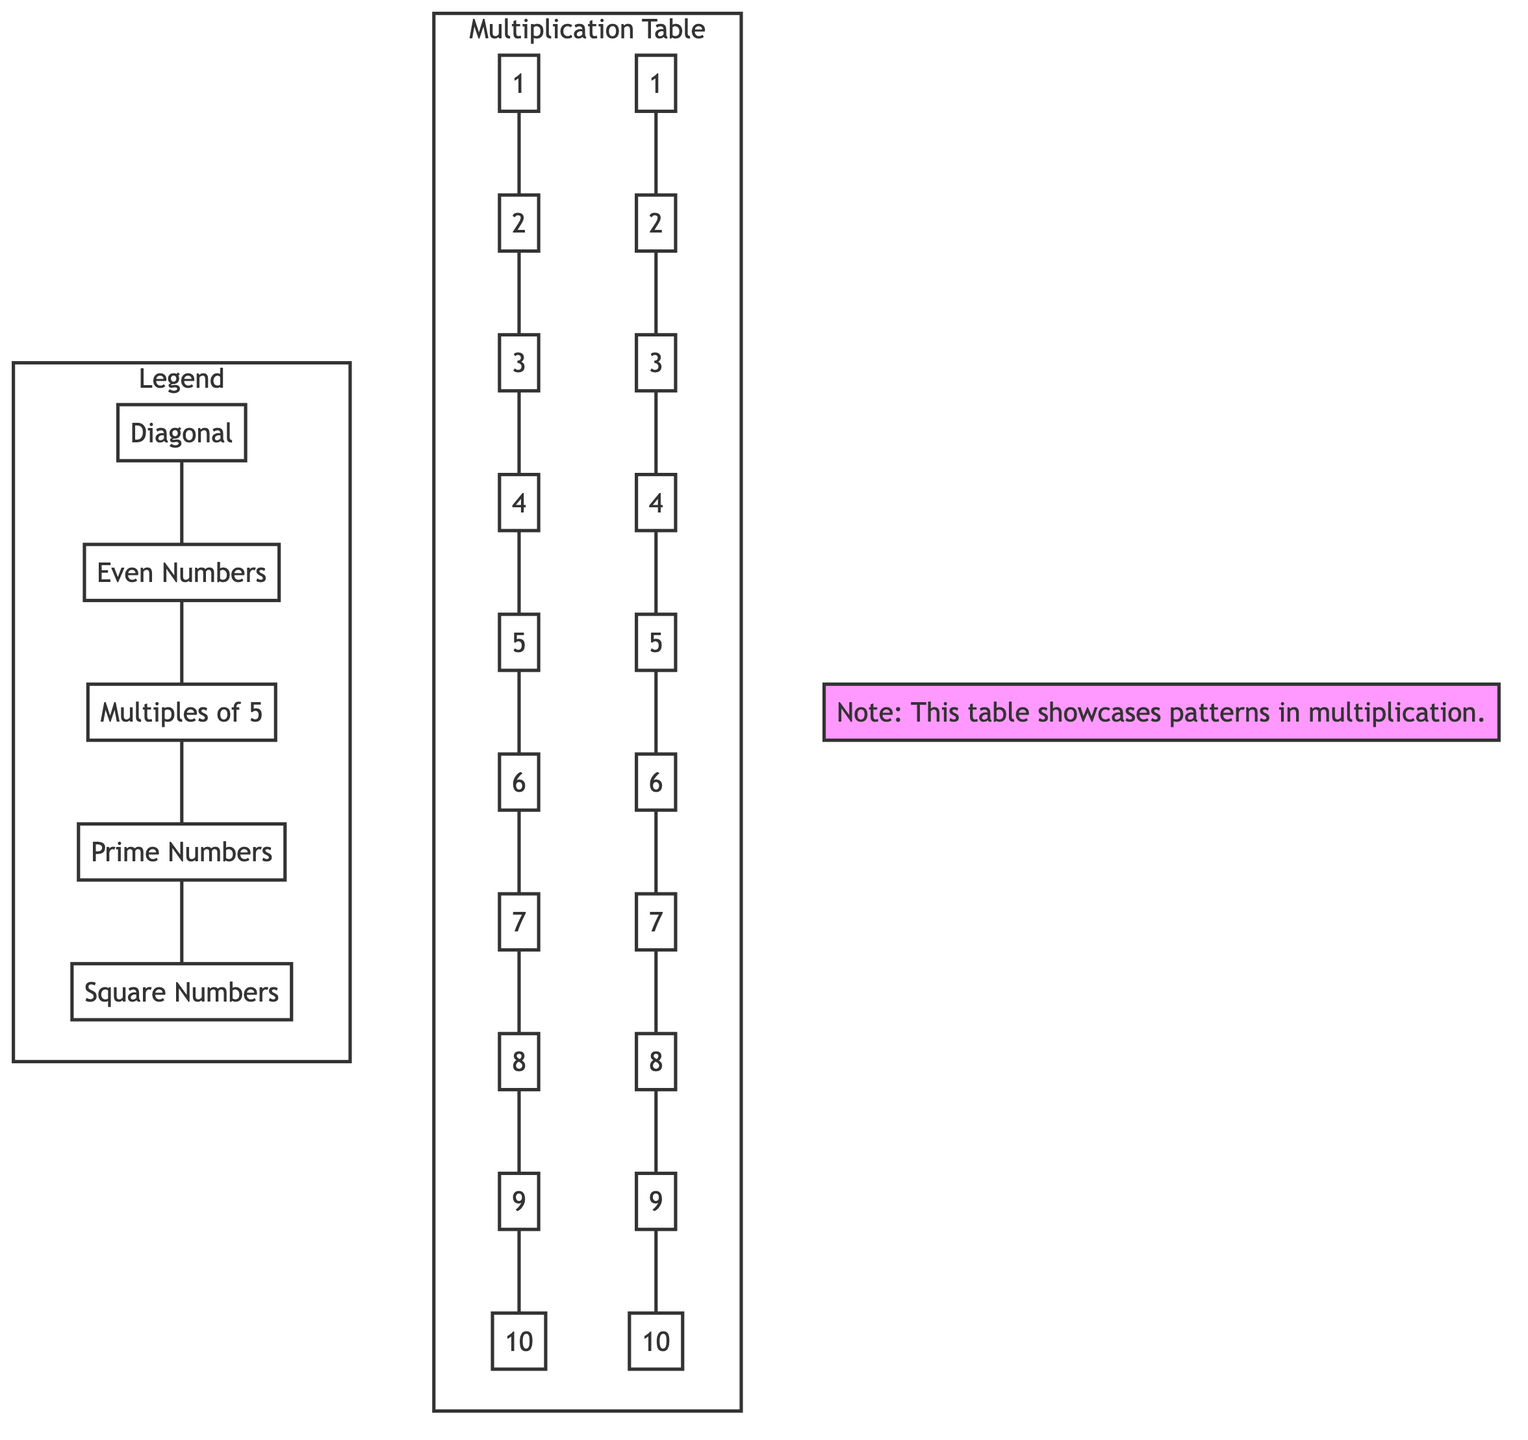What number appears at the intersection of row 2 and column 3? To find the number at the intersection of row 2 (B) and column 3 (C), we look for the multiplication result of 2 times 3, which is 6. The corresponding node, L, contains the value 6.
Answer: 6 How many prime numbers are highlighted in the table? The prime numbers in the multiplication table are represented by nodes M, Q, and S, which correspond to the values 2, 3, 5, 7. Counting these, we find there are 4 prime numbers highlighted in the table.
Answer: 4 Which color represents square numbers? Looking at the legend, the square numbers are indicated by the color pink (the code on Y), which highlights 1, 4, and 9 on the diagonal.
Answer: Pink What is the value of the node that represents 5 times 6? The node representing 5 times 6, located at the intersection of row 5 and column 6, calculates 5 times 6, which is 30. The node at this intersection contains the value 30.
Answer: 30 What color represents even numbers on the multiplication table? In the diagram's legend, even numbers are highlighted in light blue, which is used for nodes L, N, P, and R in the main grid. These nodes correspond to the values 2, 4, 6, and 8.
Answer: Light blue Count the total number of nodes in the multiplication table. The multiplication table has 10 rows and 10 columns, amounting to a total of 10 times 10 nodes. Hence, the total number of nodes in the multiplication table is 100.
Answer: 100 Which node in the table is the highest number represented? The highest number in the multiplication table is found at the intersection of row 10 (T) and column 10 (J), calculated by multiplying 10 times 10, which equals 100. The node J contains this value.
Answer: 100 What is the pattern highlighted in the diagonal of the multiplication table? The diagonal in the multiplication table shows values where the row number and column number are the same (i.e., 1 multiplied by itself), leading to the formation of perfect squares, i.e., 1, 4, 9, 16, etc.
Answer: Perfect squares Which colors are used for multiples of 5? The multiples of 5 in the table are highlighted in green (the code on W) and they correspond to the nodes at 5 and 10.
Answer: Green 